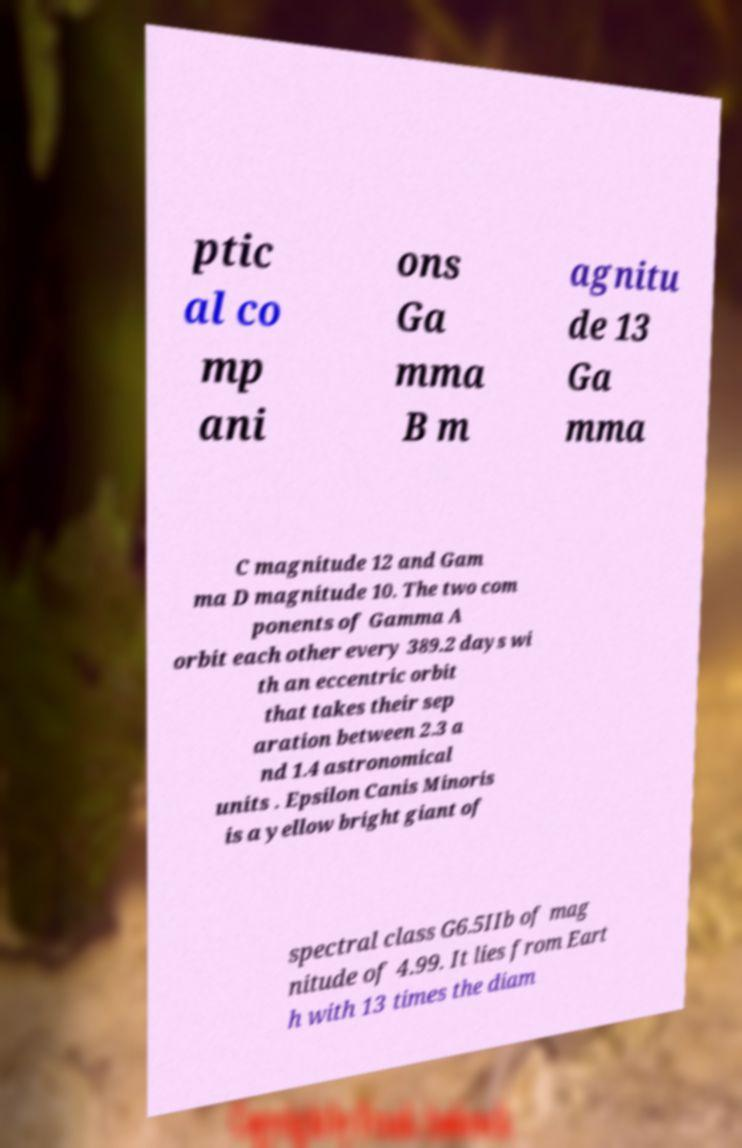For documentation purposes, I need the text within this image transcribed. Could you provide that? ptic al co mp ani ons Ga mma B m agnitu de 13 Ga mma C magnitude 12 and Gam ma D magnitude 10. The two com ponents of Gamma A orbit each other every 389.2 days wi th an eccentric orbit that takes their sep aration between 2.3 a nd 1.4 astronomical units . Epsilon Canis Minoris is a yellow bright giant of spectral class G6.5IIb of mag nitude of 4.99. It lies from Eart h with 13 times the diam 